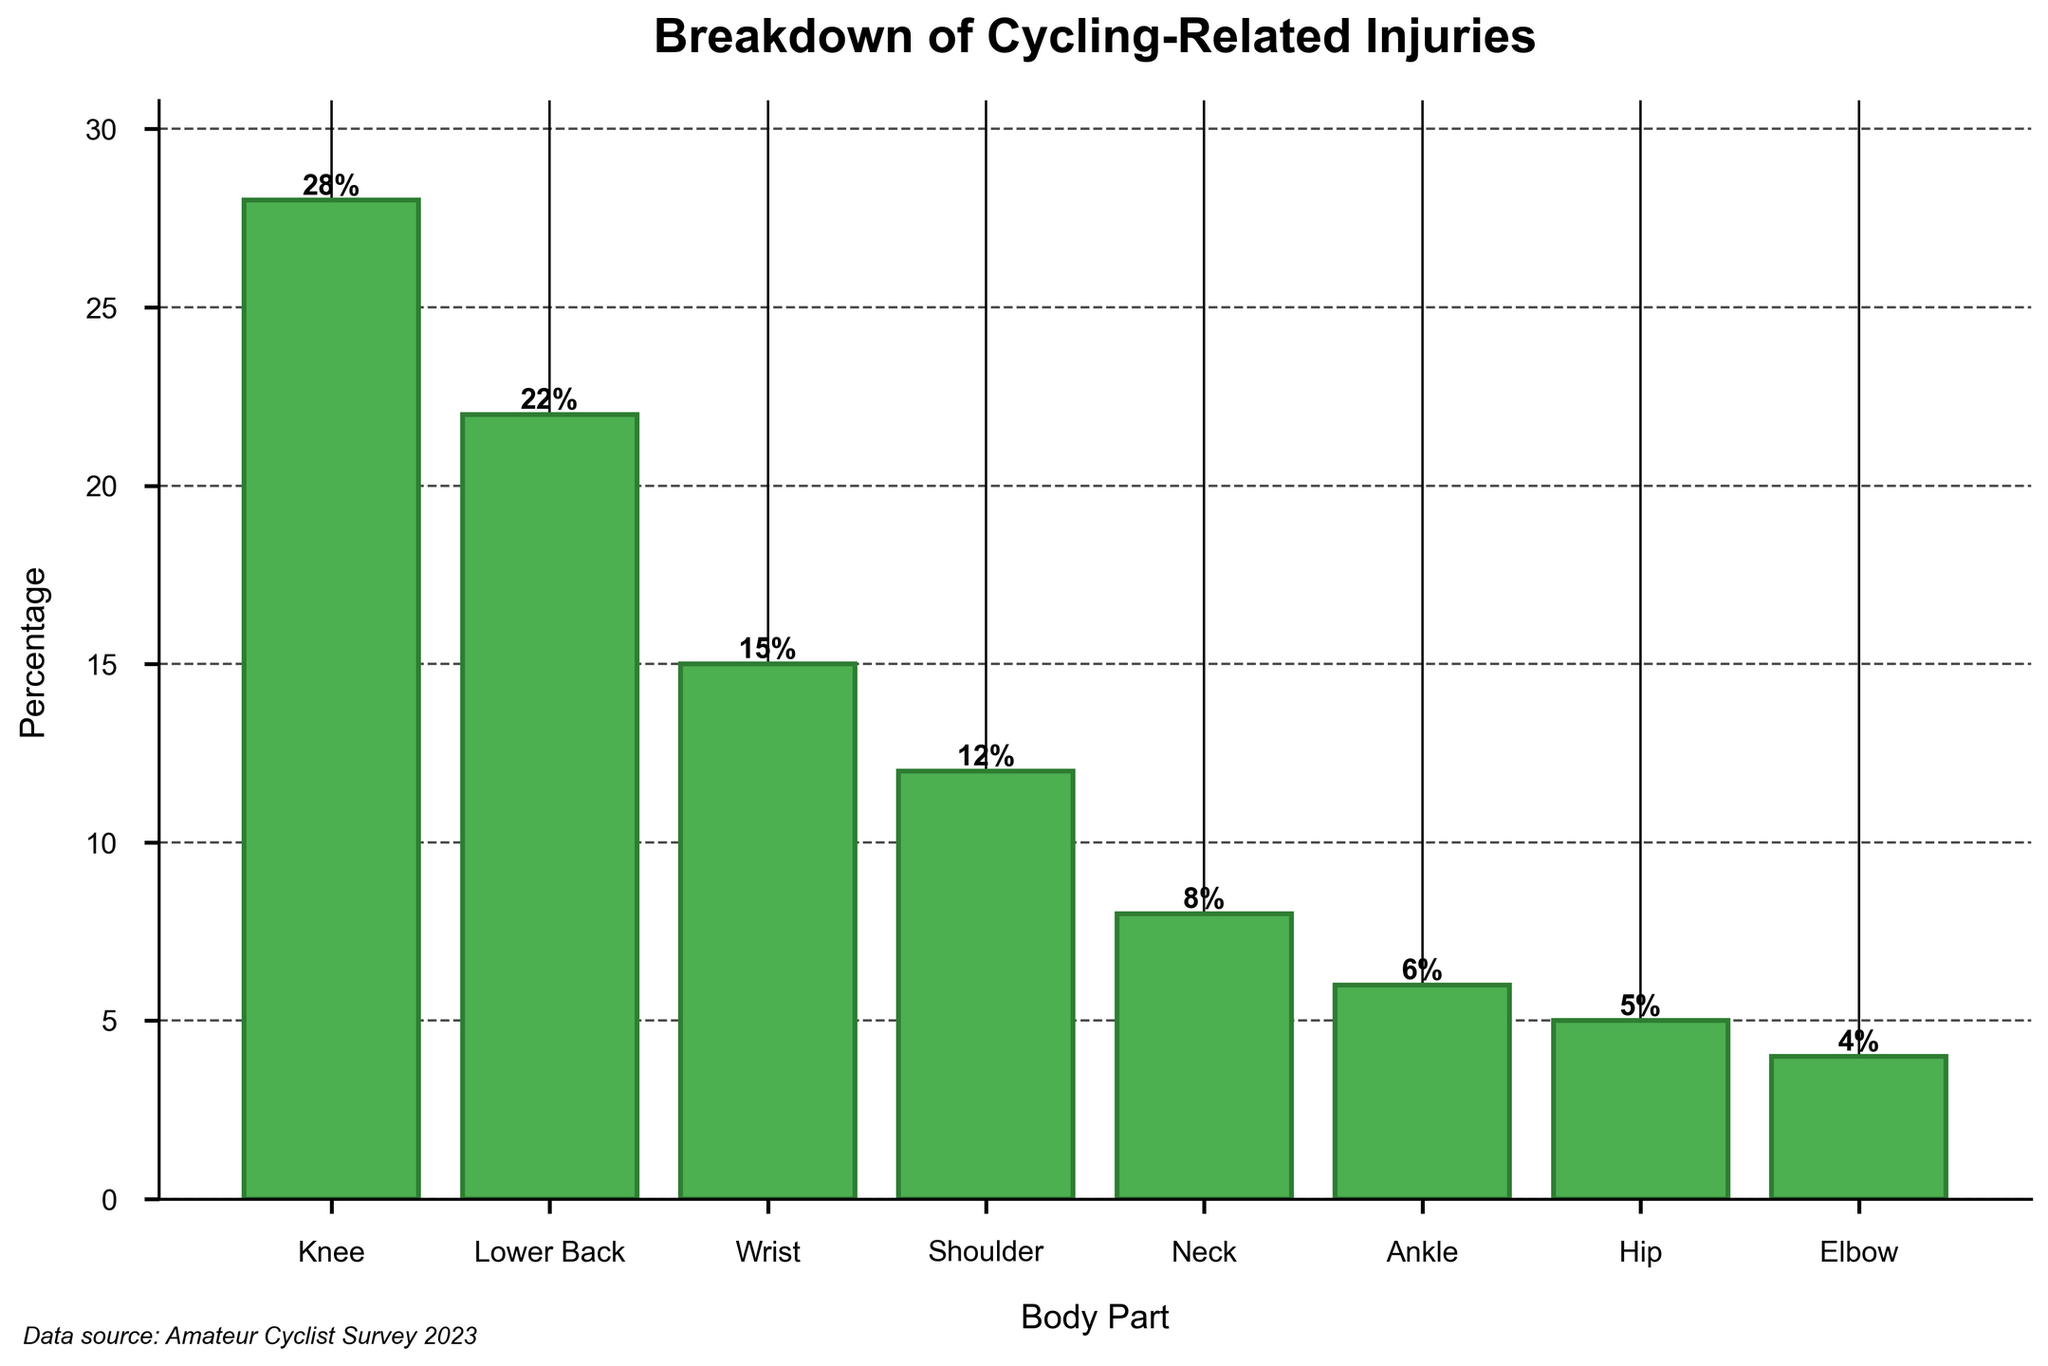What's the most common body part injured during cycling according to the chart? The highest bar in the bar chart represents the most common body part injured. In this chart, the Knee has the highest percentage with 28%.
Answer: Knee Which body part has twice as many injuries as the wrist? The wrist has 15% of injuries. The only body part with about twice this percentage is the knee, which has 28%, as 28% is almost twice 15%.
Answer: Knee What is the total percentage of injuries affecting the upper body parts (shoulder, neck, and elbow)? Add the percentages of shoulder (12%), neck (8%), and elbow (4%). 12% + 8% + 4% = 24%.
Answer: 24% Compare the percentage of knee injuries to hip injuries. How many times more likely is it for an injury to affect the knee than the hip? The percentage for knee injuries is 28% and for hip injuries is 5%. Divide 28 by 5 (28 / 5 = 5.6).
Answer: 5.6 times Is the percentage of ankle injuries higher or lower than the percentage of neck injuries? By comparing the bars, the ankle has a percentage of 6%, and the neck has a percentage of 8%.
Answer: Lower What is the combined percentage of injuries for the lower back and wrist? Add the percentages for lower back (22%) and wrist (15%). 22% + 15% = 37%.
Answer: 37% By what percentage does the prevalence of knee injuries exceed that of shoulder injuries? Subtract the percentage of shoulder injuries (12%) from knee injuries (28%). 28% - 12% = 16%.
Answer: 16% Which body part has the smallest percentage of injuries? The bar with the smallest height represents the body part with the least injuries. Here, the elbow has the smallest percentage at 4%.
Answer: Elbow How does the percentage of shoulder injuries compare to the combined percentage of hip and elbow injuries? Add the percentages for hip (5%) and elbow (4%) to get 9%. The percentage for shoulder injuries (12%) is therefore higher than the combined percentage of hip and elbow injuries.
Answer: Higher If we divide body parts into lower body (knee, ankle, hip) and upper body (lower back, wrist, shoulder, neck, elbow), which section has a higher total percentage of injuries? Add the percentages for lower body: knee (28%), ankle (6%), hip (5%). This equals 39%. Add the percentages for upper body: lower back (22%), wrist (15%), shoulder (12%), neck (8%), elbow (4%). This equals 61%.
Answer: Upper body 